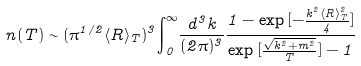Convert formula to latex. <formula><loc_0><loc_0><loc_500><loc_500>n ( T ) \sim ( { \pi } ^ { 1 / 2 } \langle R \rangle _ { T } ) ^ { 3 } { \int } ^ { \infty } _ { 0 } \frac { d ^ { 3 } { k } } { ( 2 \pi ) ^ { 3 } } \frac { 1 - { \exp { [ - \frac { k ^ { 2 } \langle R \rangle _ { T } ^ { 2 } } { 4 } ] } } } { { \exp { [ \frac { { \sqrt { k ^ { 2 } + m ^ { 2 } } } } { T } ] } } - 1 }</formula> 